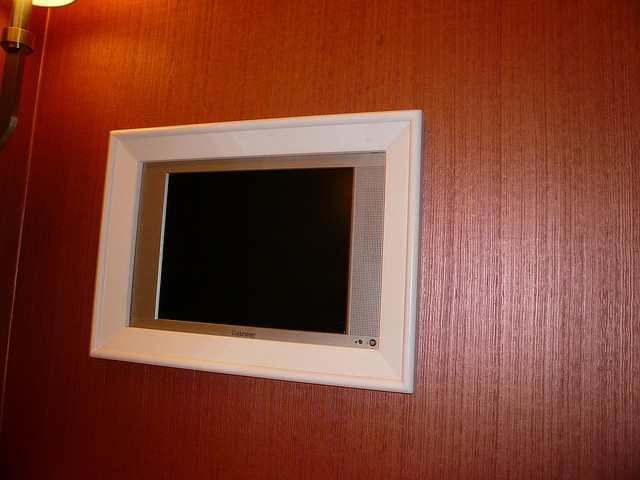Describe the objects in this image and their specific colors. I can see a tv in maroon, black, and gray tones in this image. 